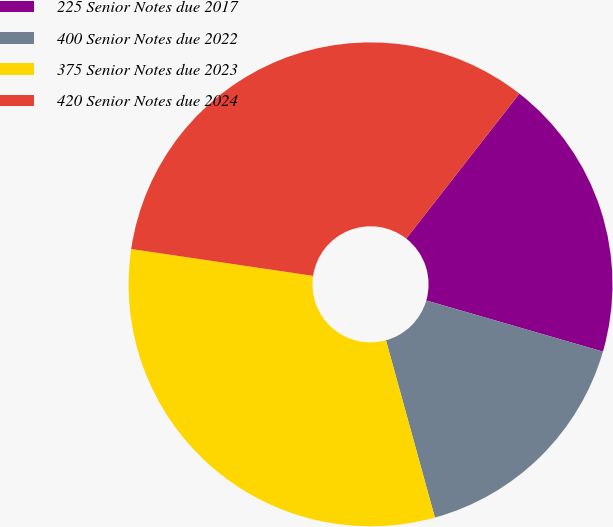<chart> <loc_0><loc_0><loc_500><loc_500><pie_chart><fcel>225 Senior Notes due 2017<fcel>400 Senior Notes due 2022<fcel>375 Senior Notes due 2023<fcel>420 Senior Notes due 2024<nl><fcel>18.94%<fcel>16.23%<fcel>31.62%<fcel>33.21%<nl></chart> 